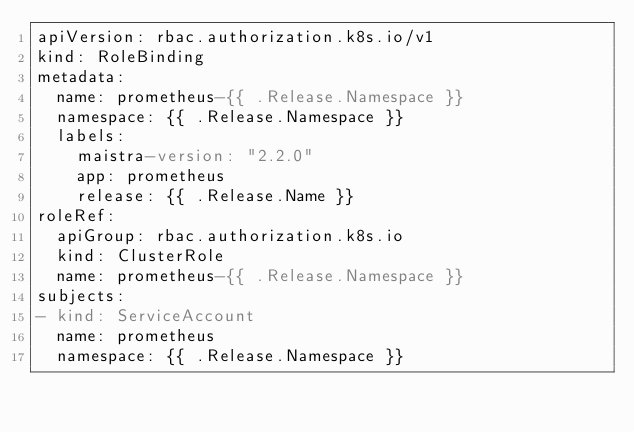Convert code to text. <code><loc_0><loc_0><loc_500><loc_500><_YAML_>apiVersion: rbac.authorization.k8s.io/v1
kind: RoleBinding
metadata:
  name: prometheus-{{ .Release.Namespace }}
  namespace: {{ .Release.Namespace }}
  labels:
    maistra-version: "2.2.0"
    app: prometheus
    release: {{ .Release.Name }}
roleRef:
  apiGroup: rbac.authorization.k8s.io
  kind: ClusterRole
  name: prometheus-{{ .Release.Namespace }}
subjects:
- kind: ServiceAccount
  name: prometheus
  namespace: {{ .Release.Namespace }}
</code> 